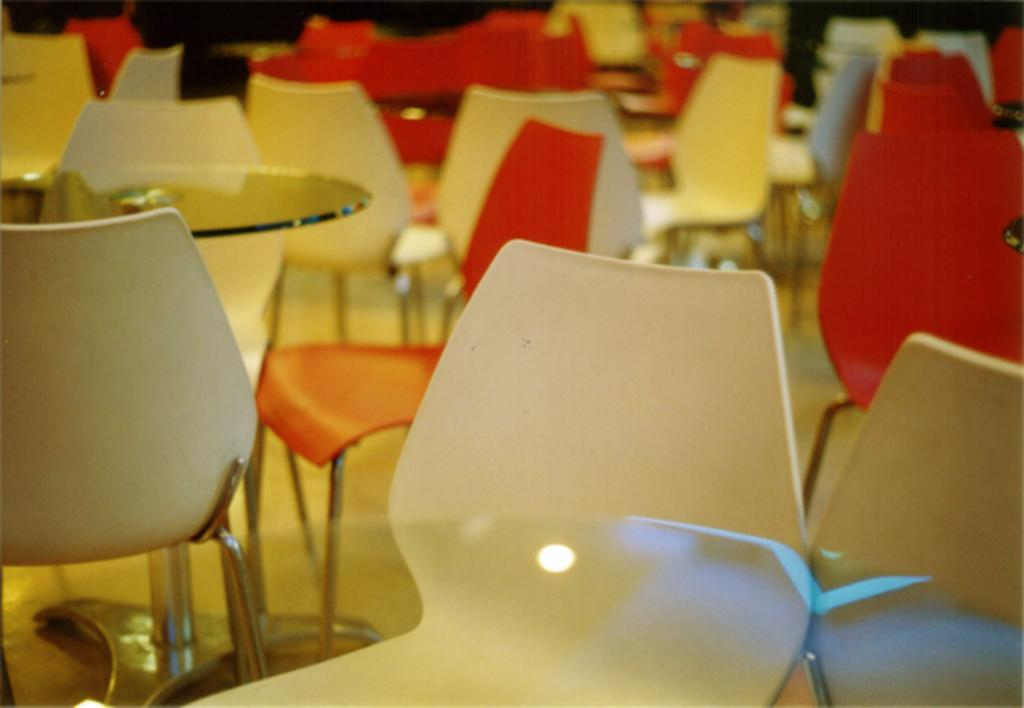What color are the chairs in the image? There are red chairs and white chairs in the image. What type of furniture is present in the image besides the chairs? There are glass tables in the image. What type of lettuce is being used as a neck pillow in the image? There is no lettuce or neck pillow present in the image. 